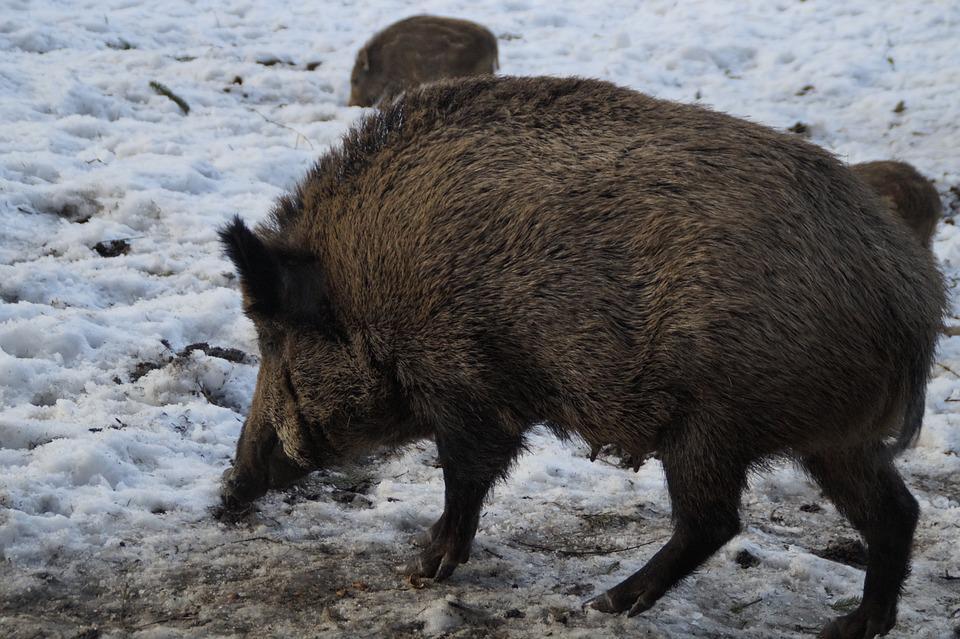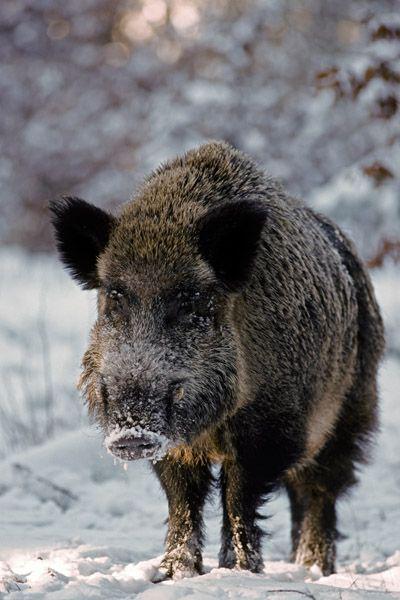The first image is the image on the left, the second image is the image on the right. Assess this claim about the two images: "There are at least two animals in one of the images.". Correct or not? Answer yes or no. No. 